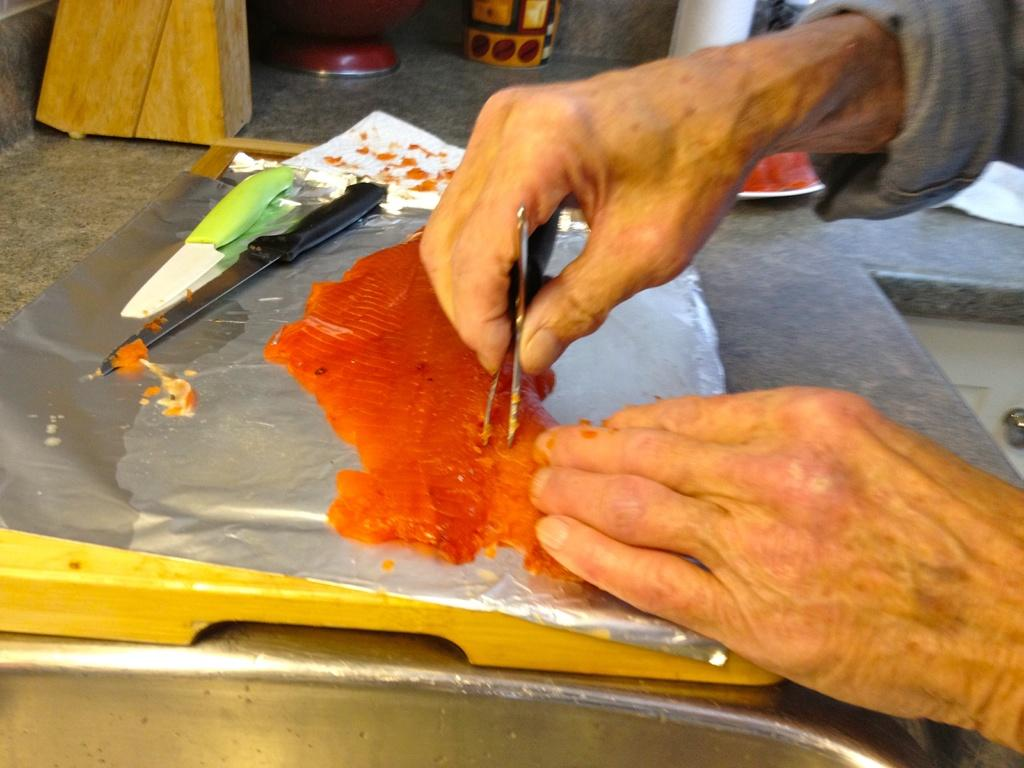What is the person in the image holding? The person is holding an object in the image. What type of sharp utensils can be seen in the image? There are knives in the image. What is being served on the tray in the image? There is food on a tray in the image. What material is the wooden object made of in the image? The wooden object in the image is made of wood. What other objects are present in the image besides the ones mentioned? There are other objects in the image. What is the cause of death for the person in the image? There is no indication of death or any related information in the image. 